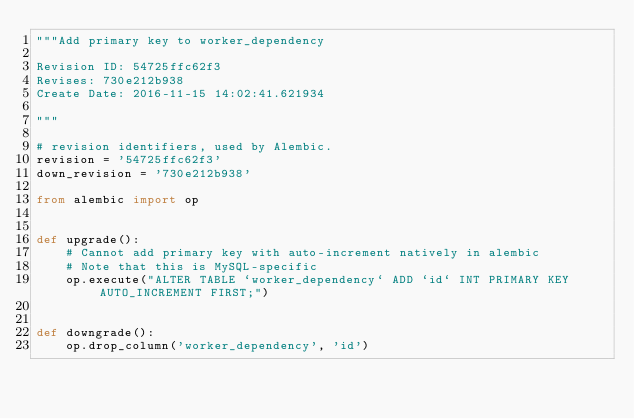Convert code to text. <code><loc_0><loc_0><loc_500><loc_500><_Python_>"""Add primary key to worker_dependency

Revision ID: 54725ffc62f3
Revises: 730e212b938
Create Date: 2016-11-15 14:02:41.621934

"""

# revision identifiers, used by Alembic.
revision = '54725ffc62f3'
down_revision = '730e212b938'

from alembic import op


def upgrade():
    # Cannot add primary key with auto-increment natively in alembic
    # Note that this is MySQL-specific
    op.execute("ALTER TABLE `worker_dependency` ADD `id` INT PRIMARY KEY AUTO_INCREMENT FIRST;")


def downgrade():
    op.drop_column('worker_dependency', 'id')
</code> 